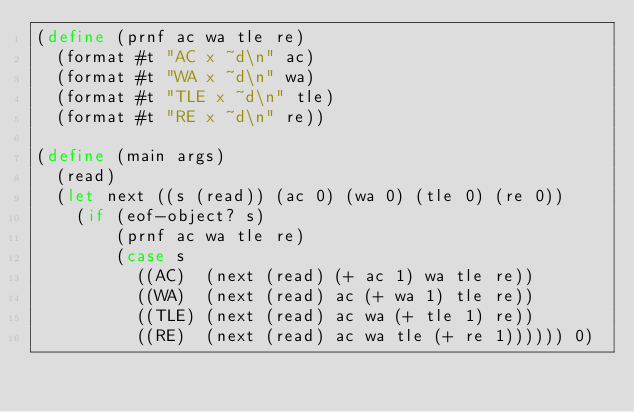<code> <loc_0><loc_0><loc_500><loc_500><_Scheme_>(define (prnf ac wa tle re)
  (format #t "AC x ~d\n" ac)
  (format #t "WA x ~d\n" wa)
  (format #t "TLE x ~d\n" tle)
  (format #t "RE x ~d\n" re))

(define (main args)
  (read)
  (let next ((s (read)) (ac 0) (wa 0) (tle 0) (re 0))
    (if (eof-object? s)
        (prnf ac wa tle re)
        (case s
          ((AC)  (next (read) (+ ac 1) wa tle re))
          ((WA)  (next (read) ac (+ wa 1) tle re))
          ((TLE) (next (read) ac wa (+ tle 1) re))
          ((RE)  (next (read) ac wa tle (+ re 1)))))) 0)
</code> 